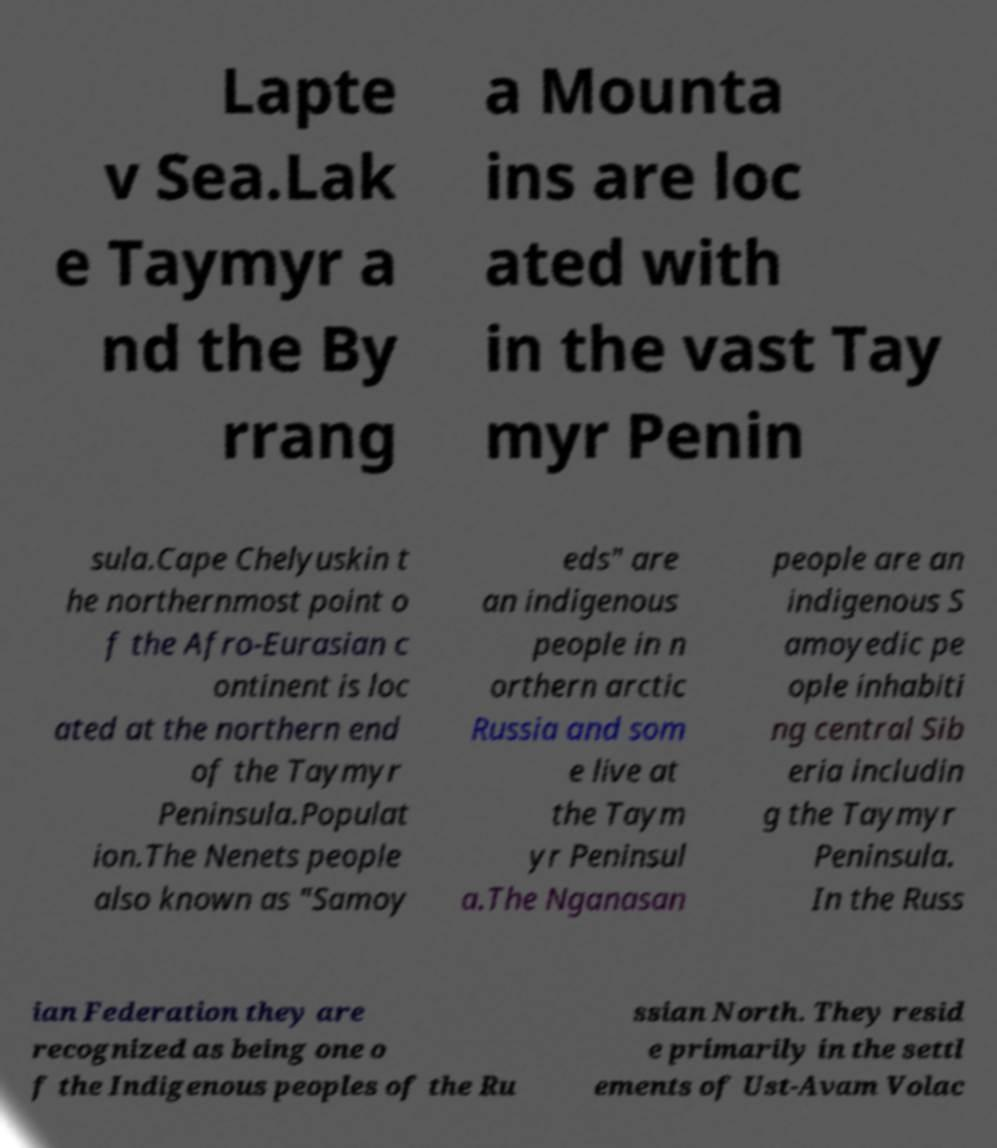Can you read and provide the text displayed in the image?This photo seems to have some interesting text. Can you extract and type it out for me? Lapte v Sea.Lak e Taymyr a nd the By rrang a Mounta ins are loc ated with in the vast Tay myr Penin sula.Cape Chelyuskin t he northernmost point o f the Afro-Eurasian c ontinent is loc ated at the northern end of the Taymyr Peninsula.Populat ion.The Nenets people also known as "Samoy eds" are an indigenous people in n orthern arctic Russia and som e live at the Taym yr Peninsul a.The Nganasan people are an indigenous S amoyedic pe ople inhabiti ng central Sib eria includin g the Taymyr Peninsula. In the Russ ian Federation they are recognized as being one o f the Indigenous peoples of the Ru ssian North. They resid e primarily in the settl ements of Ust-Avam Volac 